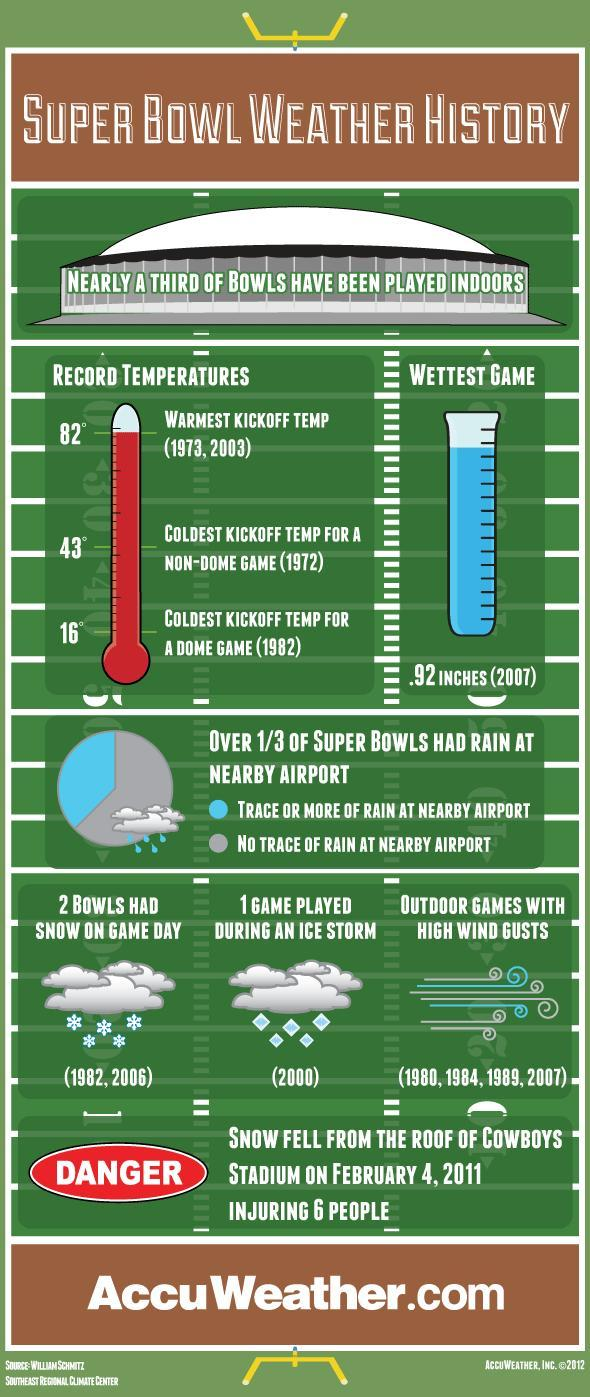When was the super bowl game played during an ice storm?
Answer the question with a short phrase. (2000) 